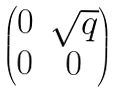<formula> <loc_0><loc_0><loc_500><loc_500>\begin{pmatrix} 0 & \sqrt { q } \\ 0 & 0 \end{pmatrix}</formula> 